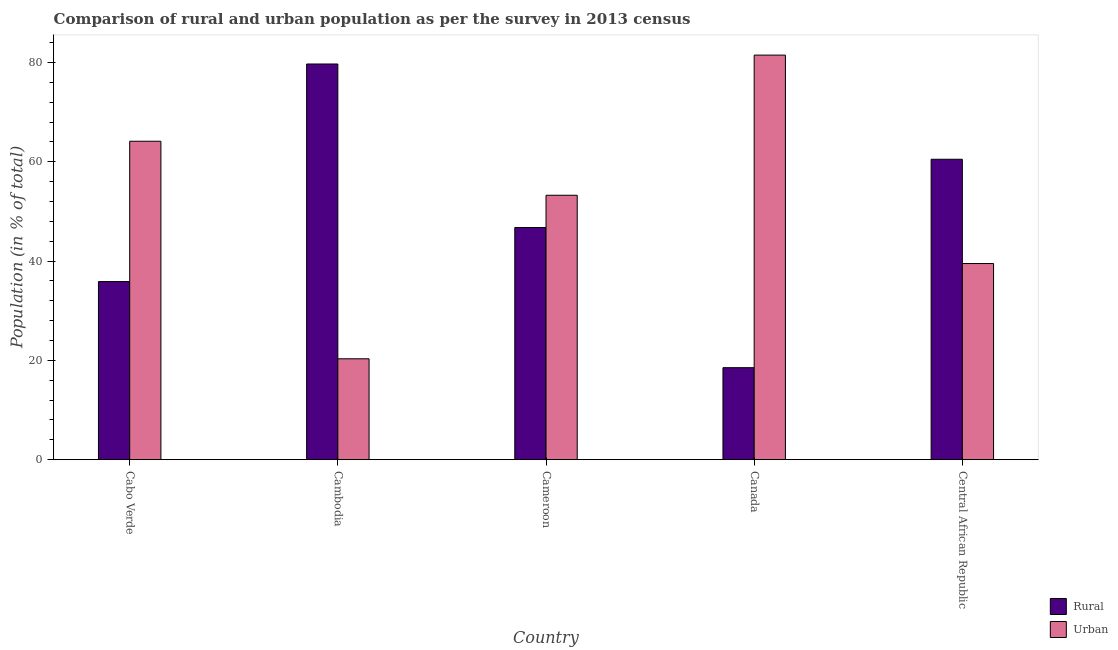How many different coloured bars are there?
Make the answer very short. 2. How many groups of bars are there?
Make the answer very short. 5. Are the number of bars per tick equal to the number of legend labels?
Your response must be concise. Yes. Are the number of bars on each tick of the X-axis equal?
Provide a short and direct response. Yes. How many bars are there on the 2nd tick from the left?
Keep it short and to the point. 2. In how many cases, is the number of bars for a given country not equal to the number of legend labels?
Your answer should be very brief. 0. What is the urban population in Cambodia?
Make the answer very short. 20.32. Across all countries, what is the maximum urban population?
Keep it short and to the point. 81.47. Across all countries, what is the minimum urban population?
Make the answer very short. 20.32. In which country was the rural population maximum?
Provide a short and direct response. Cambodia. In which country was the rural population minimum?
Offer a very short reply. Canada. What is the total rural population in the graph?
Offer a very short reply. 241.33. What is the difference between the urban population in Cabo Verde and that in Canada?
Your answer should be compact. -17.34. What is the difference between the urban population in Central African Republic and the rural population in Cabo Verde?
Your answer should be very brief. 3.63. What is the average urban population per country?
Provide a succinct answer. 51.73. What is the difference between the rural population and urban population in Cameroon?
Your answer should be very brief. -6.5. In how many countries, is the urban population greater than 8 %?
Offer a terse response. 5. What is the ratio of the rural population in Cameroon to that in Central African Republic?
Your response must be concise. 0.77. Is the urban population in Cameroon less than that in Central African Republic?
Keep it short and to the point. No. What is the difference between the highest and the second highest rural population?
Your answer should be very brief. 19.18. What is the difference between the highest and the lowest urban population?
Keep it short and to the point. 61.15. Is the sum of the rural population in Cambodia and Canada greater than the maximum urban population across all countries?
Ensure brevity in your answer.  Yes. What does the 2nd bar from the left in Cambodia represents?
Give a very brief answer. Urban. What does the 2nd bar from the right in Central African Republic represents?
Offer a very short reply. Rural. How many bars are there?
Give a very brief answer. 10. Are all the bars in the graph horizontal?
Your answer should be very brief. No. Does the graph contain grids?
Give a very brief answer. No. Where does the legend appear in the graph?
Your answer should be compact. Bottom right. How many legend labels are there?
Ensure brevity in your answer.  2. What is the title of the graph?
Keep it short and to the point. Comparison of rural and urban population as per the survey in 2013 census. Does "Female labourers" appear as one of the legend labels in the graph?
Make the answer very short. No. What is the label or title of the Y-axis?
Provide a short and direct response. Population (in % of total). What is the Population (in % of total) in Rural in Cabo Verde?
Make the answer very short. 35.87. What is the Population (in % of total) in Urban in Cabo Verde?
Provide a short and direct response. 64.13. What is the Population (in % of total) of Rural in Cambodia?
Provide a short and direct response. 79.68. What is the Population (in % of total) in Urban in Cambodia?
Your response must be concise. 20.32. What is the Population (in % of total) in Rural in Cameroon?
Keep it short and to the point. 46.75. What is the Population (in % of total) of Urban in Cameroon?
Give a very brief answer. 53.25. What is the Population (in % of total) of Rural in Canada?
Your answer should be very brief. 18.53. What is the Population (in % of total) in Urban in Canada?
Offer a terse response. 81.47. What is the Population (in % of total) of Rural in Central African Republic?
Provide a succinct answer. 60.5. What is the Population (in % of total) of Urban in Central African Republic?
Keep it short and to the point. 39.5. Across all countries, what is the maximum Population (in % of total) of Rural?
Offer a very short reply. 79.68. Across all countries, what is the maximum Population (in % of total) of Urban?
Your answer should be very brief. 81.47. Across all countries, what is the minimum Population (in % of total) in Rural?
Offer a very short reply. 18.53. Across all countries, what is the minimum Population (in % of total) in Urban?
Provide a short and direct response. 20.32. What is the total Population (in % of total) of Rural in the graph?
Provide a short and direct response. 241.33. What is the total Population (in % of total) of Urban in the graph?
Ensure brevity in your answer.  258.67. What is the difference between the Population (in % of total) in Rural in Cabo Verde and that in Cambodia?
Offer a very short reply. -43.81. What is the difference between the Population (in % of total) in Urban in Cabo Verde and that in Cambodia?
Your response must be concise. 43.81. What is the difference between the Population (in % of total) of Rural in Cabo Verde and that in Cameroon?
Keep it short and to the point. -10.88. What is the difference between the Population (in % of total) of Urban in Cabo Verde and that in Cameroon?
Offer a terse response. 10.88. What is the difference between the Population (in % of total) in Rural in Cabo Verde and that in Canada?
Provide a succinct answer. 17.34. What is the difference between the Population (in % of total) of Urban in Cabo Verde and that in Canada?
Provide a short and direct response. -17.34. What is the difference between the Population (in % of total) of Rural in Cabo Verde and that in Central African Republic?
Provide a succinct answer. -24.63. What is the difference between the Population (in % of total) of Urban in Cabo Verde and that in Central African Republic?
Provide a short and direct response. 24.63. What is the difference between the Population (in % of total) in Rural in Cambodia and that in Cameroon?
Provide a short and direct response. 32.93. What is the difference between the Population (in % of total) of Urban in Cambodia and that in Cameroon?
Offer a very short reply. -32.93. What is the difference between the Population (in % of total) in Rural in Cambodia and that in Canada?
Offer a very short reply. 61.15. What is the difference between the Population (in % of total) in Urban in Cambodia and that in Canada?
Keep it short and to the point. -61.15. What is the difference between the Population (in % of total) of Rural in Cambodia and that in Central African Republic?
Give a very brief answer. 19.18. What is the difference between the Population (in % of total) in Urban in Cambodia and that in Central African Republic?
Give a very brief answer. -19.18. What is the difference between the Population (in % of total) in Rural in Cameroon and that in Canada?
Make the answer very short. 28.22. What is the difference between the Population (in % of total) of Urban in Cameroon and that in Canada?
Give a very brief answer. -28.22. What is the difference between the Population (in % of total) in Rural in Cameroon and that in Central African Republic?
Offer a terse response. -13.75. What is the difference between the Population (in % of total) in Urban in Cameroon and that in Central African Republic?
Provide a succinct answer. 13.75. What is the difference between the Population (in % of total) in Rural in Canada and that in Central African Republic?
Your answer should be compact. -41.97. What is the difference between the Population (in % of total) of Urban in Canada and that in Central African Republic?
Keep it short and to the point. 41.97. What is the difference between the Population (in % of total) in Rural in Cabo Verde and the Population (in % of total) in Urban in Cambodia?
Make the answer very short. 15.55. What is the difference between the Population (in % of total) in Rural in Cabo Verde and the Population (in % of total) in Urban in Cameroon?
Provide a succinct answer. -17.38. What is the difference between the Population (in % of total) of Rural in Cabo Verde and the Population (in % of total) of Urban in Canada?
Offer a very short reply. -45.6. What is the difference between the Population (in % of total) of Rural in Cabo Verde and the Population (in % of total) of Urban in Central African Republic?
Keep it short and to the point. -3.63. What is the difference between the Population (in % of total) in Rural in Cambodia and the Population (in % of total) in Urban in Cameroon?
Provide a succinct answer. 26.43. What is the difference between the Population (in % of total) of Rural in Cambodia and the Population (in % of total) of Urban in Canada?
Give a very brief answer. -1.79. What is the difference between the Population (in % of total) in Rural in Cambodia and the Population (in % of total) in Urban in Central African Republic?
Offer a terse response. 40.18. What is the difference between the Population (in % of total) in Rural in Cameroon and the Population (in % of total) in Urban in Canada?
Your response must be concise. -34.72. What is the difference between the Population (in % of total) in Rural in Cameroon and the Population (in % of total) in Urban in Central African Republic?
Offer a very short reply. 7.25. What is the difference between the Population (in % of total) of Rural in Canada and the Population (in % of total) of Urban in Central African Republic?
Your response must be concise. -20.97. What is the average Population (in % of total) in Rural per country?
Your response must be concise. 48.27. What is the average Population (in % of total) of Urban per country?
Your response must be concise. 51.73. What is the difference between the Population (in % of total) of Rural and Population (in % of total) of Urban in Cabo Verde?
Ensure brevity in your answer.  -28.25. What is the difference between the Population (in % of total) of Rural and Population (in % of total) of Urban in Cambodia?
Ensure brevity in your answer.  59.36. What is the difference between the Population (in % of total) in Rural and Population (in % of total) in Urban in Cameroon?
Offer a terse response. -6.5. What is the difference between the Population (in % of total) in Rural and Population (in % of total) in Urban in Canada?
Offer a terse response. -62.94. What is the ratio of the Population (in % of total) of Rural in Cabo Verde to that in Cambodia?
Your answer should be compact. 0.45. What is the ratio of the Population (in % of total) in Urban in Cabo Verde to that in Cambodia?
Ensure brevity in your answer.  3.16. What is the ratio of the Population (in % of total) in Rural in Cabo Verde to that in Cameroon?
Provide a short and direct response. 0.77. What is the ratio of the Population (in % of total) in Urban in Cabo Verde to that in Cameroon?
Provide a succinct answer. 1.2. What is the ratio of the Population (in % of total) of Rural in Cabo Verde to that in Canada?
Make the answer very short. 1.94. What is the ratio of the Population (in % of total) in Urban in Cabo Verde to that in Canada?
Give a very brief answer. 0.79. What is the ratio of the Population (in % of total) in Rural in Cabo Verde to that in Central African Republic?
Your answer should be very brief. 0.59. What is the ratio of the Population (in % of total) in Urban in Cabo Verde to that in Central African Republic?
Provide a short and direct response. 1.62. What is the ratio of the Population (in % of total) in Rural in Cambodia to that in Cameroon?
Keep it short and to the point. 1.7. What is the ratio of the Population (in % of total) of Urban in Cambodia to that in Cameroon?
Your answer should be very brief. 0.38. What is the ratio of the Population (in % of total) of Rural in Cambodia to that in Canada?
Provide a short and direct response. 4.3. What is the ratio of the Population (in % of total) of Urban in Cambodia to that in Canada?
Provide a short and direct response. 0.25. What is the ratio of the Population (in % of total) of Rural in Cambodia to that in Central African Republic?
Ensure brevity in your answer.  1.32. What is the ratio of the Population (in % of total) in Urban in Cambodia to that in Central African Republic?
Your answer should be compact. 0.51. What is the ratio of the Population (in % of total) in Rural in Cameroon to that in Canada?
Keep it short and to the point. 2.52. What is the ratio of the Population (in % of total) in Urban in Cameroon to that in Canada?
Your response must be concise. 0.65. What is the ratio of the Population (in % of total) in Rural in Cameroon to that in Central African Republic?
Provide a short and direct response. 0.77. What is the ratio of the Population (in % of total) in Urban in Cameroon to that in Central African Republic?
Give a very brief answer. 1.35. What is the ratio of the Population (in % of total) of Rural in Canada to that in Central African Republic?
Make the answer very short. 0.31. What is the ratio of the Population (in % of total) of Urban in Canada to that in Central African Republic?
Ensure brevity in your answer.  2.06. What is the difference between the highest and the second highest Population (in % of total) in Rural?
Provide a short and direct response. 19.18. What is the difference between the highest and the second highest Population (in % of total) of Urban?
Provide a succinct answer. 17.34. What is the difference between the highest and the lowest Population (in % of total) in Rural?
Give a very brief answer. 61.15. What is the difference between the highest and the lowest Population (in % of total) in Urban?
Ensure brevity in your answer.  61.15. 